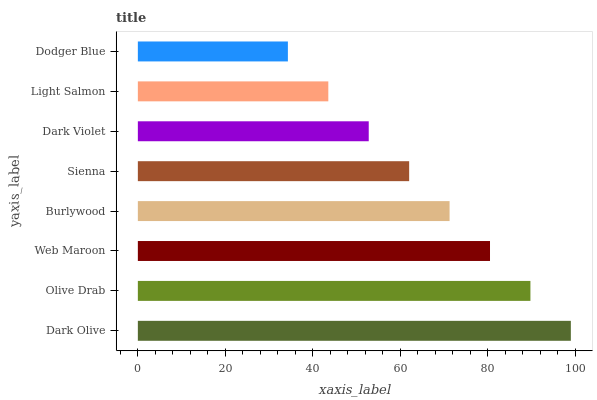Is Dodger Blue the minimum?
Answer yes or no. Yes. Is Dark Olive the maximum?
Answer yes or no. Yes. Is Olive Drab the minimum?
Answer yes or no. No. Is Olive Drab the maximum?
Answer yes or no. No. Is Dark Olive greater than Olive Drab?
Answer yes or no. Yes. Is Olive Drab less than Dark Olive?
Answer yes or no. Yes. Is Olive Drab greater than Dark Olive?
Answer yes or no. No. Is Dark Olive less than Olive Drab?
Answer yes or no. No. Is Burlywood the high median?
Answer yes or no. Yes. Is Sienna the low median?
Answer yes or no. Yes. Is Web Maroon the high median?
Answer yes or no. No. Is Dark Olive the low median?
Answer yes or no. No. 